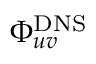<formula> <loc_0><loc_0><loc_500><loc_500>\Phi _ { u v } ^ { D N S }</formula> 